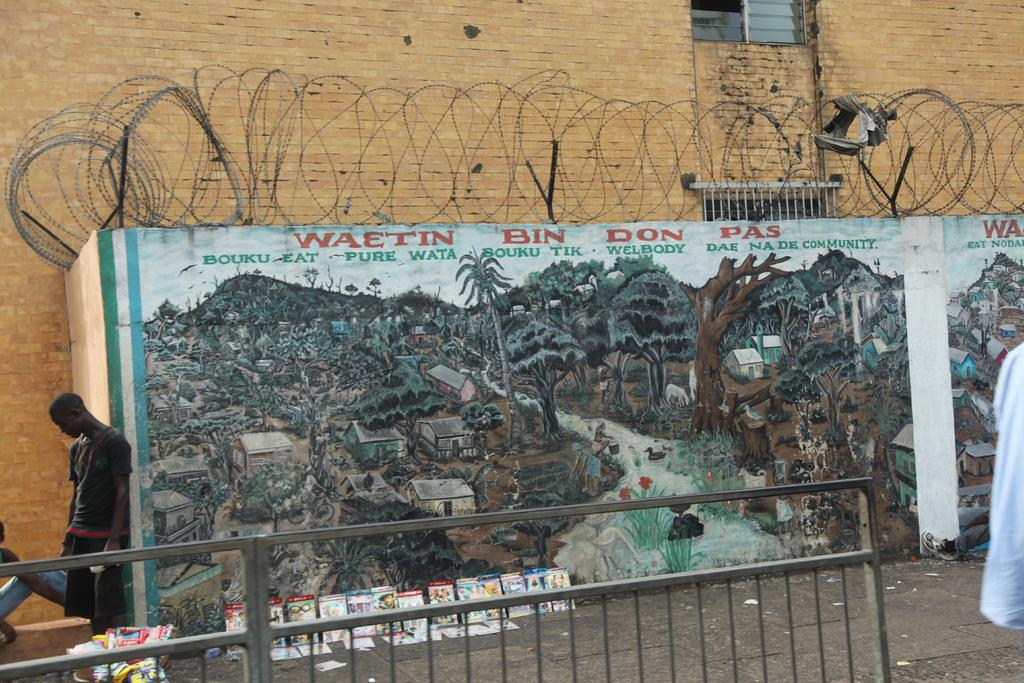What are the people in the image doing? The people in the image are standing and sitting on the road. What objects can be seen in addition to the people? Books are visible in the image. What is on the wall in the image? Paintings are present on the wall. What type of barrier can be seen in the image? Fences are visible in the image. What type of silver object is being used by the people in the image? There is no silver object visible in the image. Can you read the letter that is being passed around in the image? There is no letter being passed around in the image. 